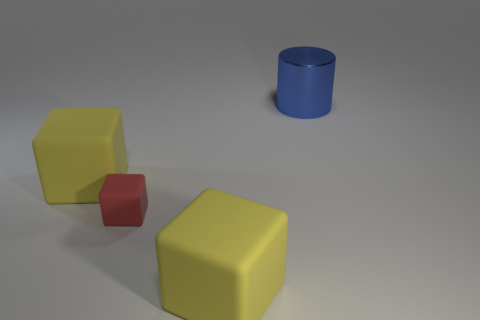Are there any other things that are the same size as the red object?
Make the answer very short. No. Is there a big block that has the same material as the tiny red thing?
Offer a very short reply. Yes. Is the number of big yellow things greater than the number of small red matte things?
Give a very brief answer. Yes. How many metal things are either tiny gray objects or big blocks?
Offer a very short reply. 0. What number of other large matte objects are the same shape as the red object?
Ensure brevity in your answer.  2. How many blocks are tiny green shiny objects or red objects?
Your response must be concise. 1. Is the shape of the yellow thing behind the tiny cube the same as the large blue shiny thing that is on the right side of the tiny matte object?
Your response must be concise. No. What is the material of the big blue cylinder?
Offer a terse response. Metal. How many blue objects are the same size as the cylinder?
Provide a short and direct response. 0. How many things are large yellow matte objects in front of the red thing or big objects that are to the left of the large blue cylinder?
Provide a succinct answer. 2. 